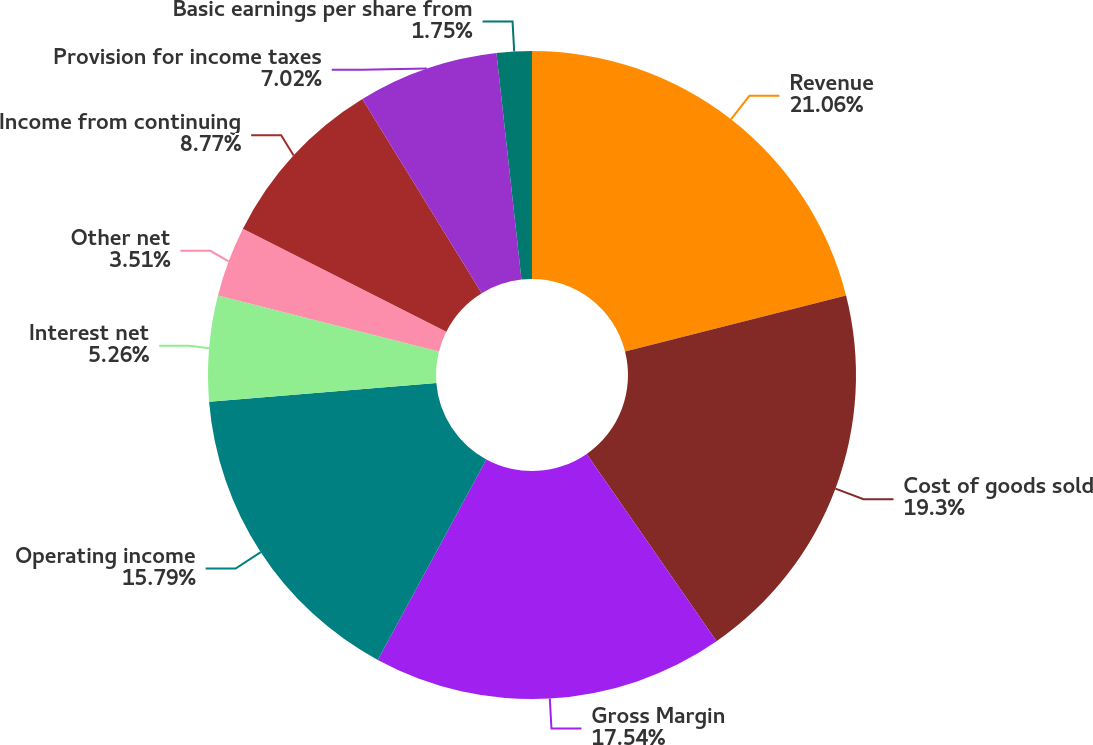Convert chart to OTSL. <chart><loc_0><loc_0><loc_500><loc_500><pie_chart><fcel>Revenue<fcel>Cost of goods sold<fcel>Gross Margin<fcel>Operating income<fcel>Interest net<fcel>Other net<fcel>Income from continuing<fcel>Provision for income taxes<fcel>Basic earnings per share from<nl><fcel>21.05%<fcel>19.3%<fcel>17.54%<fcel>15.79%<fcel>5.26%<fcel>3.51%<fcel>8.77%<fcel>7.02%<fcel>1.75%<nl></chart> 